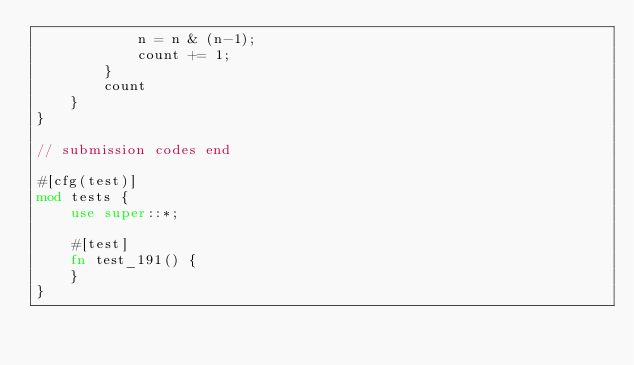Convert code to text. <code><loc_0><loc_0><loc_500><loc_500><_Rust_>            n = n & (n-1);
            count += 1;
        }
        count
    }
}

// submission codes end

#[cfg(test)]
mod tests {
    use super::*;

    #[test]
    fn test_191() {
    }
}
</code> 